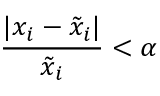Convert formula to latex. <formula><loc_0><loc_0><loc_500><loc_500>\frac { | x _ { i } - \tilde { x } _ { i } | } { \tilde { x } _ { i } } < \alpha</formula> 